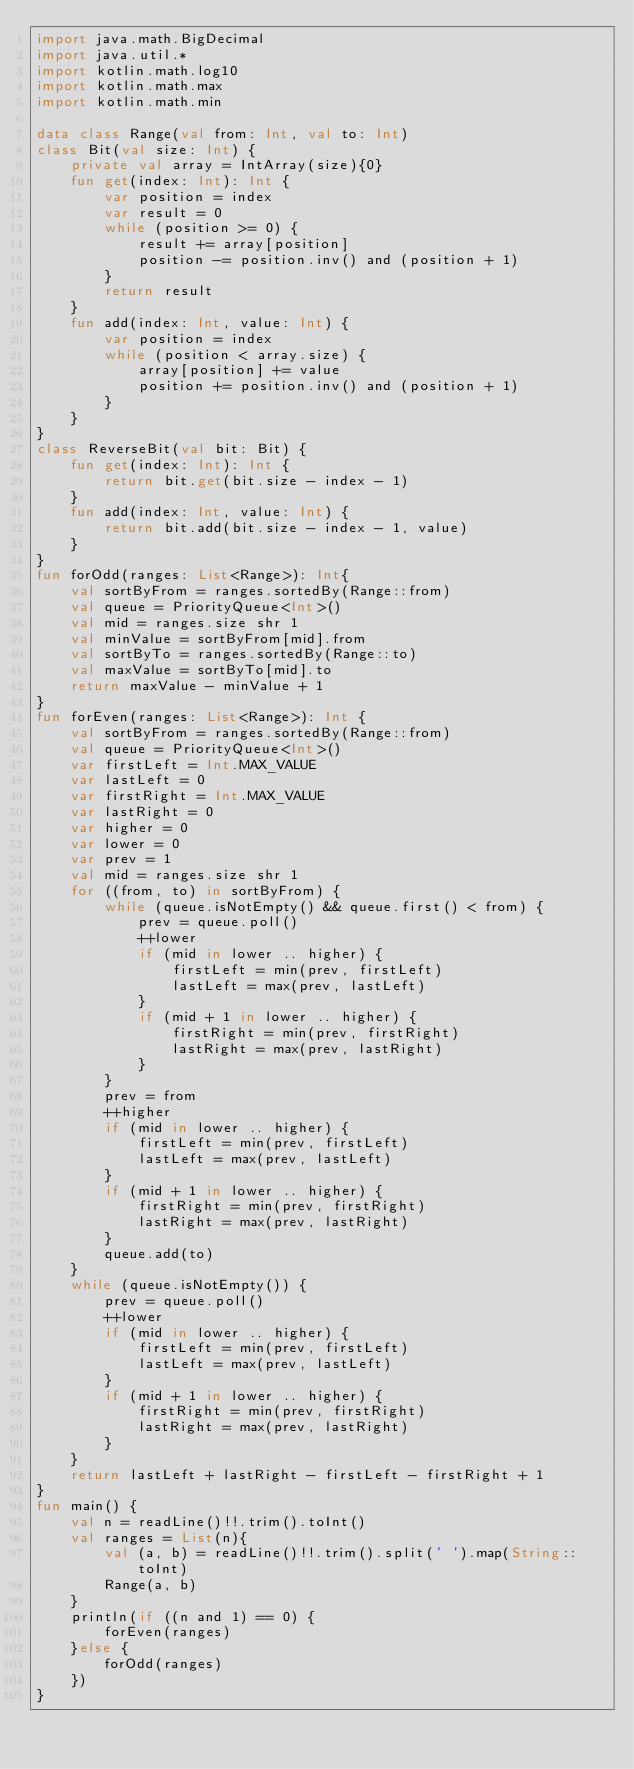<code> <loc_0><loc_0><loc_500><loc_500><_Kotlin_>import java.math.BigDecimal
import java.util.*
import kotlin.math.log10
import kotlin.math.max
import kotlin.math.min

data class Range(val from: Int, val to: Int)
class Bit(val size: Int) {
    private val array = IntArray(size){0}
    fun get(index: Int): Int {
        var position = index
        var result = 0
        while (position >= 0) {
            result += array[position]
            position -= position.inv() and (position + 1)
        }
        return result
    }
    fun add(index: Int, value: Int) {
        var position = index
        while (position < array.size) {
            array[position] += value
            position += position.inv() and (position + 1)
        }
    }
}
class ReverseBit(val bit: Bit) {
    fun get(index: Int): Int {
        return bit.get(bit.size - index - 1)
    }
    fun add(index: Int, value: Int) {
        return bit.add(bit.size - index - 1, value)
    }
}
fun forOdd(ranges: List<Range>): Int{
    val sortByFrom = ranges.sortedBy(Range::from)
    val queue = PriorityQueue<Int>()
    val mid = ranges.size shr 1
    val minValue = sortByFrom[mid].from
    val sortByTo = ranges.sortedBy(Range::to)
    val maxValue = sortByTo[mid].to
    return maxValue - minValue + 1
}
fun forEven(ranges: List<Range>): Int {
    val sortByFrom = ranges.sortedBy(Range::from)
    val queue = PriorityQueue<Int>()
    var firstLeft = Int.MAX_VALUE
    var lastLeft = 0
    var firstRight = Int.MAX_VALUE
    var lastRight = 0
    var higher = 0
    var lower = 0
    var prev = 1
    val mid = ranges.size shr 1
    for ((from, to) in sortByFrom) {
        while (queue.isNotEmpty() && queue.first() < from) {
            prev = queue.poll()
            ++lower
            if (mid in lower .. higher) {
                firstLeft = min(prev, firstLeft)
                lastLeft = max(prev, lastLeft)
            }
            if (mid + 1 in lower .. higher) {
                firstRight = min(prev, firstRight)
                lastRight = max(prev, lastRight)
            }
        }
        prev = from
        ++higher
        if (mid in lower .. higher) {
            firstLeft = min(prev, firstLeft)
            lastLeft = max(prev, lastLeft)
        }
        if (mid + 1 in lower .. higher) {
            firstRight = min(prev, firstRight)
            lastRight = max(prev, lastRight)
        }
        queue.add(to)
    }
    while (queue.isNotEmpty()) {
        prev = queue.poll()
        ++lower
        if (mid in lower .. higher) {
            firstLeft = min(prev, firstLeft)
            lastLeft = max(prev, lastLeft)
        }
        if (mid + 1 in lower .. higher) {
            firstRight = min(prev, firstRight)
            lastRight = max(prev, lastRight)
        }
    }
    return lastLeft + lastRight - firstLeft - firstRight + 1
}
fun main() {
    val n = readLine()!!.trim().toInt()
    val ranges = List(n){
        val (a, b) = readLine()!!.trim().split(' ').map(String::toInt)
        Range(a, b)
    }
    println(if ((n and 1) == 0) {
        forEven(ranges)
    }else {
        forOdd(ranges)
    })
}
</code> 